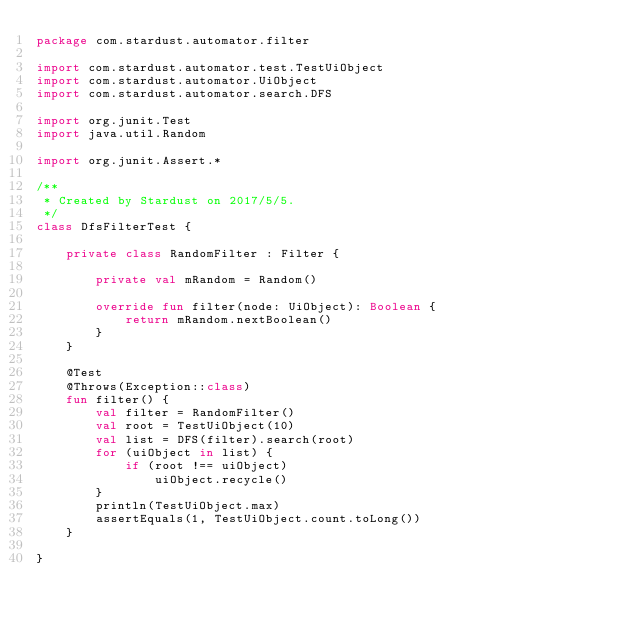Convert code to text. <code><loc_0><loc_0><loc_500><loc_500><_Kotlin_>package com.stardust.automator.filter

import com.stardust.automator.test.TestUiObject
import com.stardust.automator.UiObject
import com.stardust.automator.search.DFS

import org.junit.Test
import java.util.Random

import org.junit.Assert.*

/**
 * Created by Stardust on 2017/5/5.
 */
class DfsFilterTest {

    private class RandomFilter : Filter {

        private val mRandom = Random()

        override fun filter(node: UiObject): Boolean {
            return mRandom.nextBoolean()
        }
    }

    @Test
    @Throws(Exception::class)
    fun filter() {
        val filter = RandomFilter()
        val root = TestUiObject(10)
        val list = DFS(filter).search(root)
        for (uiObject in list) {
            if (root !== uiObject)
                uiObject.recycle()
        }
        println(TestUiObject.max)
        assertEquals(1, TestUiObject.count.toLong())
    }

}</code> 